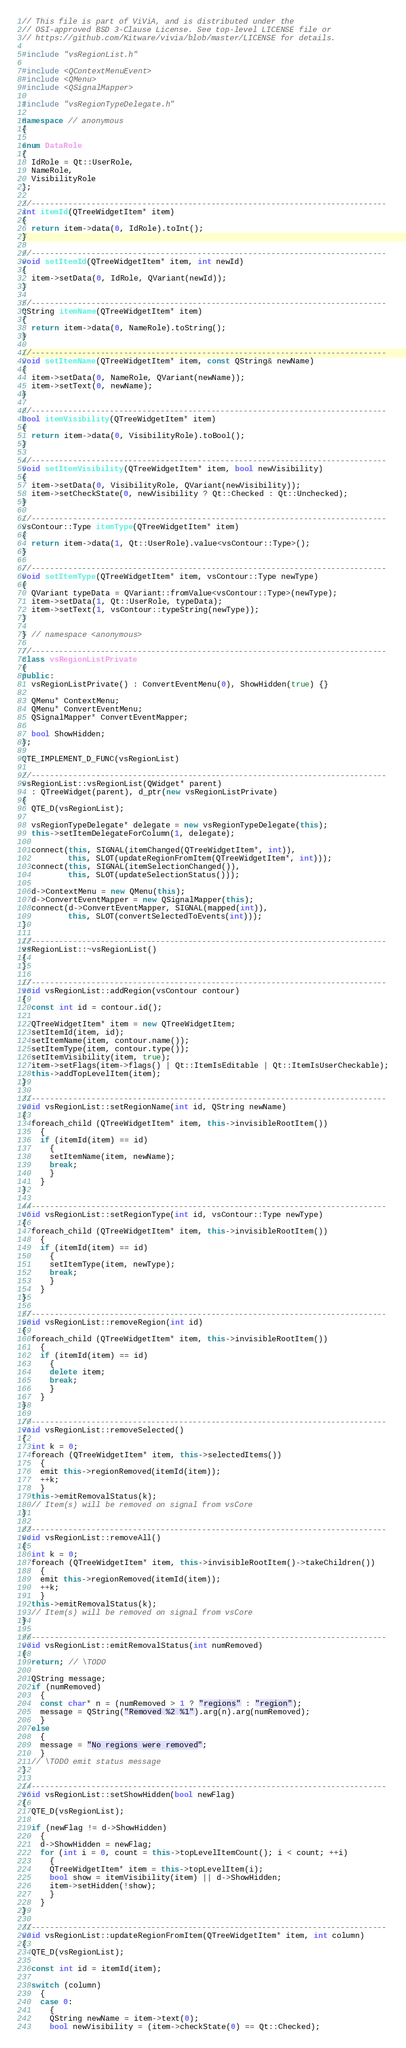Convert code to text. <code><loc_0><loc_0><loc_500><loc_500><_C++_>// This file is part of ViViA, and is distributed under the
// OSI-approved BSD 3-Clause License. See top-level LICENSE file or
// https://github.com/Kitware/vivia/blob/master/LICENSE for details.

#include "vsRegionList.h"

#include <QContextMenuEvent>
#include <QMenu>
#include <QSignalMapper>

#include "vsRegionTypeDelegate.h"

namespace // anonymous
{

enum DataRole
{
  IdRole = Qt::UserRole,
  NameRole,
  VisibilityRole
};

//-----------------------------------------------------------------------------
int itemId(QTreeWidgetItem* item)
{
  return item->data(0, IdRole).toInt();
}

//-----------------------------------------------------------------------------
void setItemId(QTreeWidgetItem* item, int newId)
{
  item->setData(0, IdRole, QVariant(newId));
}

//-----------------------------------------------------------------------------
QString itemName(QTreeWidgetItem* item)
{
  return item->data(0, NameRole).toString();
}

//-----------------------------------------------------------------------------
void setItemName(QTreeWidgetItem* item, const QString& newName)
{
  item->setData(0, NameRole, QVariant(newName));
  item->setText(0, newName);
}

//-----------------------------------------------------------------------------
bool itemVisibility(QTreeWidgetItem* item)
{
  return item->data(0, VisibilityRole).toBool();
}

//-----------------------------------------------------------------------------
void setItemVisibility(QTreeWidgetItem* item, bool newVisibility)
{
  item->setData(0, VisibilityRole, QVariant(newVisibility));
  item->setCheckState(0, newVisibility ? Qt::Checked : Qt::Unchecked);
}

//-----------------------------------------------------------------------------
vsContour::Type itemType(QTreeWidgetItem* item)
{
  return item->data(1, Qt::UserRole).value<vsContour::Type>();
}

//-----------------------------------------------------------------------------
void setItemType(QTreeWidgetItem* item, vsContour::Type newType)
{
  QVariant typeData = QVariant::fromValue<vsContour::Type>(newType);
  item->setData(1, Qt::UserRole, typeData);
  item->setText(1, vsContour::typeString(newType));
}

} // namespace <anonymous>

//-----------------------------------------------------------------------------
class vsRegionListPrivate
{
public:
  vsRegionListPrivate() : ConvertEventMenu(0), ShowHidden(true) {}

  QMenu* ContextMenu;
  QMenu* ConvertEventMenu;
  QSignalMapper* ConvertEventMapper;

  bool ShowHidden;
};

QTE_IMPLEMENT_D_FUNC(vsRegionList)

//-----------------------------------------------------------------------------
vsRegionList::vsRegionList(QWidget* parent)
  : QTreeWidget(parent), d_ptr(new vsRegionListPrivate)
{
  QTE_D(vsRegionList);

  vsRegionTypeDelegate* delegate = new vsRegionTypeDelegate(this);
  this->setItemDelegateForColumn(1, delegate);

  connect(this, SIGNAL(itemChanged(QTreeWidgetItem*, int)),
          this, SLOT(updateRegionFromItem(QTreeWidgetItem*, int)));
  connect(this, SIGNAL(itemSelectionChanged()),
          this, SLOT(updateSelectionStatus()));

  d->ContextMenu = new QMenu(this);
  d->ConvertEventMapper = new QSignalMapper(this);
  connect(d->ConvertEventMapper, SIGNAL(mapped(int)),
          this, SLOT(convertSelectedToEvents(int)));
}

//-----------------------------------------------------------------------------
vsRegionList::~vsRegionList()
{
}

//-----------------------------------------------------------------------------
void vsRegionList::addRegion(vsContour contour)
{
  const int id = contour.id();

  QTreeWidgetItem* item = new QTreeWidgetItem;
  setItemId(item, id);
  setItemName(item, contour.name());
  setItemType(item, contour.type());
  setItemVisibility(item, true);
  item->setFlags(item->flags() | Qt::ItemIsEditable | Qt::ItemIsUserCheckable);
  this->addTopLevelItem(item);
}

//-----------------------------------------------------------------------------
void vsRegionList::setRegionName(int id, QString newName)
{
  foreach_child (QTreeWidgetItem* item, this->invisibleRootItem())
    {
    if (itemId(item) == id)
      {
      setItemName(item, newName);
      break;
      }
    }
}

//-----------------------------------------------------------------------------
void vsRegionList::setRegionType(int id, vsContour::Type newType)
{
  foreach_child (QTreeWidgetItem* item, this->invisibleRootItem())
    {
    if (itemId(item) == id)
      {
      setItemType(item, newType);
      break;
      }
    }
}

//-----------------------------------------------------------------------------
void vsRegionList::removeRegion(int id)
{
  foreach_child (QTreeWidgetItem* item, this->invisibleRootItem())
    {
    if (itemId(item) == id)
      {
      delete item;
      break;
      }
    }
}

//-----------------------------------------------------------------------------
void vsRegionList::removeSelected()
{
  int k = 0;
  foreach (QTreeWidgetItem* item, this->selectedItems())
    {
    emit this->regionRemoved(itemId(item));
    ++k;
    }
  this->emitRemovalStatus(k);
  // Item(s) will be removed on signal from vsCore
}

//-----------------------------------------------------------------------------
void vsRegionList::removeAll()
{
  int k = 0;
  foreach (QTreeWidgetItem* item, this->invisibleRootItem()->takeChildren())
    {
    emit this->regionRemoved(itemId(item));
    ++k;
    }
  this->emitRemovalStatus(k);
  // Item(s) will be removed on signal from vsCore
}

//-----------------------------------------------------------------------------
void vsRegionList::emitRemovalStatus(int numRemoved)
{
  return; // \TODO

  QString message;
  if (numRemoved)
    {
    const char* n = (numRemoved > 1 ? "regions" : "region");
    message = QString("Removed %2 %1").arg(n).arg(numRemoved);
    }
  else
    {
    message = "No regions were removed";
    }
  // \TODO emit status message
}

//-----------------------------------------------------------------------------
void vsRegionList::setShowHidden(bool newFlag)
{
  QTE_D(vsRegionList);

  if (newFlag != d->ShowHidden)
    {
    d->ShowHidden = newFlag;
    for (int i = 0, count = this->topLevelItemCount(); i < count; ++i)
      {
      QTreeWidgetItem* item = this->topLevelItem(i);
      bool show = itemVisibility(item) || d->ShowHidden;
      item->setHidden(!show);
      }
    }
}

//-----------------------------------------------------------------------------
void vsRegionList::updateRegionFromItem(QTreeWidgetItem* item, int column)
{
  QTE_D(vsRegionList);

  const int id = itemId(item);

  switch (column)
    {
    case 0:
      {
      QString newName = item->text(0);
      bool newVisibility = (item->checkState(0) == Qt::Checked);
</code> 